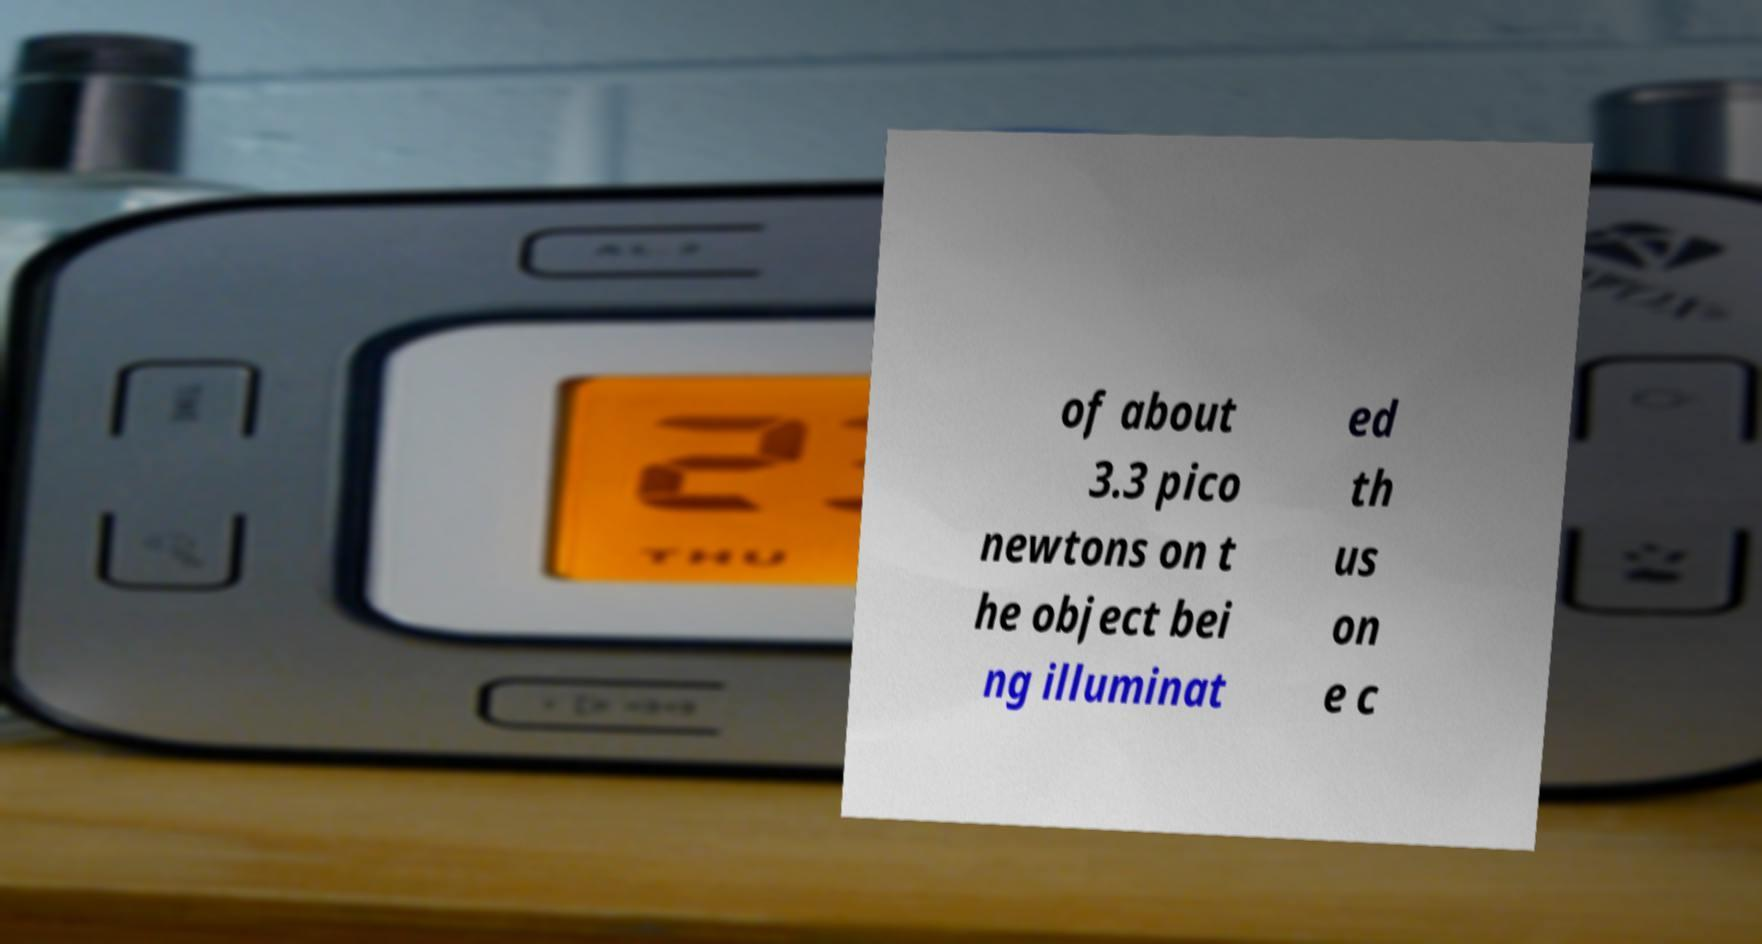I need the written content from this picture converted into text. Can you do that? of about 3.3 pico newtons on t he object bei ng illuminat ed th us on e c 